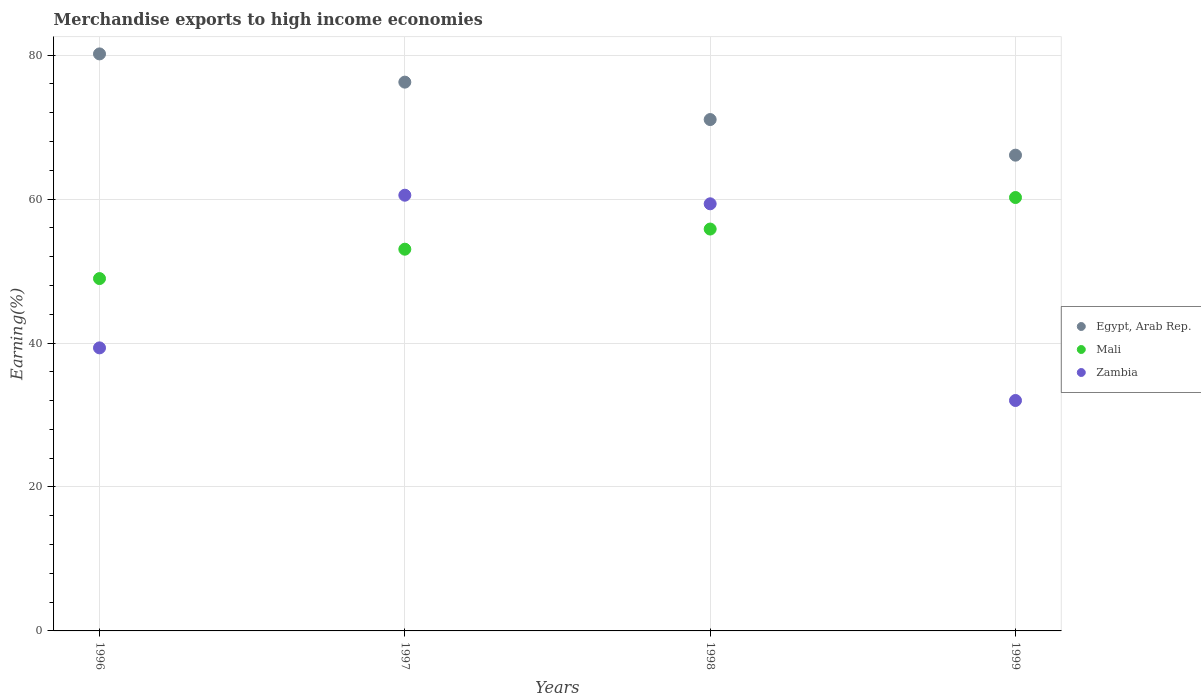Is the number of dotlines equal to the number of legend labels?
Provide a short and direct response. Yes. What is the percentage of amount earned from merchandise exports in Egypt, Arab Rep. in 1996?
Offer a terse response. 80.17. Across all years, what is the maximum percentage of amount earned from merchandise exports in Egypt, Arab Rep.?
Offer a terse response. 80.17. Across all years, what is the minimum percentage of amount earned from merchandise exports in Egypt, Arab Rep.?
Offer a terse response. 66.1. In which year was the percentage of amount earned from merchandise exports in Mali minimum?
Offer a terse response. 1996. What is the total percentage of amount earned from merchandise exports in Mali in the graph?
Ensure brevity in your answer.  218.04. What is the difference between the percentage of amount earned from merchandise exports in Zambia in 1996 and that in 1997?
Your answer should be very brief. -21.21. What is the difference between the percentage of amount earned from merchandise exports in Egypt, Arab Rep. in 1997 and the percentage of amount earned from merchandise exports in Mali in 1999?
Make the answer very short. 16.03. What is the average percentage of amount earned from merchandise exports in Mali per year?
Keep it short and to the point. 54.51. In the year 1998, what is the difference between the percentage of amount earned from merchandise exports in Mali and percentage of amount earned from merchandise exports in Egypt, Arab Rep.?
Ensure brevity in your answer.  -15.21. What is the ratio of the percentage of amount earned from merchandise exports in Zambia in 1996 to that in 1998?
Your answer should be very brief. 0.66. Is the percentage of amount earned from merchandise exports in Egypt, Arab Rep. in 1996 less than that in 1999?
Ensure brevity in your answer.  No. What is the difference between the highest and the second highest percentage of amount earned from merchandise exports in Zambia?
Your response must be concise. 1.19. What is the difference between the highest and the lowest percentage of amount earned from merchandise exports in Egypt, Arab Rep.?
Provide a short and direct response. 14.07. In how many years, is the percentage of amount earned from merchandise exports in Mali greater than the average percentage of amount earned from merchandise exports in Mali taken over all years?
Offer a very short reply. 2. Is the sum of the percentage of amount earned from merchandise exports in Egypt, Arab Rep. in 1997 and 1998 greater than the maximum percentage of amount earned from merchandise exports in Mali across all years?
Provide a succinct answer. Yes. Does the percentage of amount earned from merchandise exports in Egypt, Arab Rep. monotonically increase over the years?
Your response must be concise. No. Is the percentage of amount earned from merchandise exports in Zambia strictly greater than the percentage of amount earned from merchandise exports in Egypt, Arab Rep. over the years?
Offer a very short reply. No. How many years are there in the graph?
Provide a short and direct response. 4. Does the graph contain any zero values?
Provide a succinct answer. No. Where does the legend appear in the graph?
Provide a succinct answer. Center right. What is the title of the graph?
Your answer should be compact. Merchandise exports to high income economies. What is the label or title of the X-axis?
Give a very brief answer. Years. What is the label or title of the Y-axis?
Ensure brevity in your answer.  Earning(%). What is the Earning(%) in Egypt, Arab Rep. in 1996?
Your answer should be very brief. 80.17. What is the Earning(%) in Mali in 1996?
Offer a very short reply. 48.95. What is the Earning(%) in Zambia in 1996?
Give a very brief answer. 39.32. What is the Earning(%) of Egypt, Arab Rep. in 1997?
Offer a terse response. 76.25. What is the Earning(%) of Mali in 1997?
Ensure brevity in your answer.  53.03. What is the Earning(%) of Zambia in 1997?
Make the answer very short. 60.54. What is the Earning(%) in Egypt, Arab Rep. in 1998?
Provide a succinct answer. 71.05. What is the Earning(%) in Mali in 1998?
Make the answer very short. 55.83. What is the Earning(%) in Zambia in 1998?
Provide a succinct answer. 59.34. What is the Earning(%) of Egypt, Arab Rep. in 1999?
Provide a short and direct response. 66.1. What is the Earning(%) of Mali in 1999?
Ensure brevity in your answer.  60.21. What is the Earning(%) in Zambia in 1999?
Provide a succinct answer. 32.01. Across all years, what is the maximum Earning(%) in Egypt, Arab Rep.?
Ensure brevity in your answer.  80.17. Across all years, what is the maximum Earning(%) of Mali?
Your response must be concise. 60.21. Across all years, what is the maximum Earning(%) of Zambia?
Offer a terse response. 60.54. Across all years, what is the minimum Earning(%) of Egypt, Arab Rep.?
Provide a short and direct response. 66.1. Across all years, what is the minimum Earning(%) in Mali?
Your answer should be compact. 48.95. Across all years, what is the minimum Earning(%) in Zambia?
Ensure brevity in your answer.  32.01. What is the total Earning(%) of Egypt, Arab Rep. in the graph?
Your response must be concise. 293.56. What is the total Earning(%) in Mali in the graph?
Your answer should be very brief. 218.04. What is the total Earning(%) of Zambia in the graph?
Offer a very short reply. 191.22. What is the difference between the Earning(%) in Egypt, Arab Rep. in 1996 and that in 1997?
Ensure brevity in your answer.  3.92. What is the difference between the Earning(%) in Mali in 1996 and that in 1997?
Give a very brief answer. -4.08. What is the difference between the Earning(%) of Zambia in 1996 and that in 1997?
Your response must be concise. -21.21. What is the difference between the Earning(%) of Egypt, Arab Rep. in 1996 and that in 1998?
Make the answer very short. 9.12. What is the difference between the Earning(%) in Mali in 1996 and that in 1998?
Your response must be concise. -6.88. What is the difference between the Earning(%) in Zambia in 1996 and that in 1998?
Provide a succinct answer. -20.02. What is the difference between the Earning(%) of Egypt, Arab Rep. in 1996 and that in 1999?
Keep it short and to the point. 14.07. What is the difference between the Earning(%) in Mali in 1996 and that in 1999?
Make the answer very short. -11.26. What is the difference between the Earning(%) in Zambia in 1996 and that in 1999?
Your response must be concise. 7.31. What is the difference between the Earning(%) in Egypt, Arab Rep. in 1997 and that in 1998?
Provide a short and direct response. 5.2. What is the difference between the Earning(%) in Mali in 1997 and that in 1998?
Give a very brief answer. -2.8. What is the difference between the Earning(%) of Zambia in 1997 and that in 1998?
Give a very brief answer. 1.19. What is the difference between the Earning(%) in Egypt, Arab Rep. in 1997 and that in 1999?
Give a very brief answer. 10.15. What is the difference between the Earning(%) of Mali in 1997 and that in 1999?
Your answer should be very brief. -7.18. What is the difference between the Earning(%) of Zambia in 1997 and that in 1999?
Offer a terse response. 28.52. What is the difference between the Earning(%) of Egypt, Arab Rep. in 1998 and that in 1999?
Provide a succinct answer. 4.95. What is the difference between the Earning(%) of Mali in 1998 and that in 1999?
Ensure brevity in your answer.  -4.38. What is the difference between the Earning(%) in Zambia in 1998 and that in 1999?
Your answer should be very brief. 27.33. What is the difference between the Earning(%) of Egypt, Arab Rep. in 1996 and the Earning(%) of Mali in 1997?
Your answer should be very brief. 27.13. What is the difference between the Earning(%) of Egypt, Arab Rep. in 1996 and the Earning(%) of Zambia in 1997?
Provide a short and direct response. 19.63. What is the difference between the Earning(%) in Mali in 1996 and the Earning(%) in Zambia in 1997?
Offer a very short reply. -11.58. What is the difference between the Earning(%) of Egypt, Arab Rep. in 1996 and the Earning(%) of Mali in 1998?
Ensure brevity in your answer.  24.33. What is the difference between the Earning(%) of Egypt, Arab Rep. in 1996 and the Earning(%) of Zambia in 1998?
Make the answer very short. 20.83. What is the difference between the Earning(%) in Mali in 1996 and the Earning(%) in Zambia in 1998?
Offer a very short reply. -10.39. What is the difference between the Earning(%) in Egypt, Arab Rep. in 1996 and the Earning(%) in Mali in 1999?
Your response must be concise. 19.95. What is the difference between the Earning(%) of Egypt, Arab Rep. in 1996 and the Earning(%) of Zambia in 1999?
Your answer should be compact. 48.15. What is the difference between the Earning(%) in Mali in 1996 and the Earning(%) in Zambia in 1999?
Keep it short and to the point. 16.94. What is the difference between the Earning(%) in Egypt, Arab Rep. in 1997 and the Earning(%) in Mali in 1998?
Provide a short and direct response. 20.41. What is the difference between the Earning(%) in Egypt, Arab Rep. in 1997 and the Earning(%) in Zambia in 1998?
Your response must be concise. 16.9. What is the difference between the Earning(%) of Mali in 1997 and the Earning(%) of Zambia in 1998?
Offer a terse response. -6.31. What is the difference between the Earning(%) in Egypt, Arab Rep. in 1997 and the Earning(%) in Mali in 1999?
Offer a terse response. 16.03. What is the difference between the Earning(%) of Egypt, Arab Rep. in 1997 and the Earning(%) of Zambia in 1999?
Your answer should be very brief. 44.23. What is the difference between the Earning(%) of Mali in 1997 and the Earning(%) of Zambia in 1999?
Keep it short and to the point. 21.02. What is the difference between the Earning(%) of Egypt, Arab Rep. in 1998 and the Earning(%) of Mali in 1999?
Your response must be concise. 10.83. What is the difference between the Earning(%) of Egypt, Arab Rep. in 1998 and the Earning(%) of Zambia in 1999?
Your answer should be compact. 39.03. What is the difference between the Earning(%) in Mali in 1998 and the Earning(%) in Zambia in 1999?
Offer a terse response. 23.82. What is the average Earning(%) of Egypt, Arab Rep. per year?
Give a very brief answer. 73.39. What is the average Earning(%) of Mali per year?
Provide a short and direct response. 54.51. What is the average Earning(%) in Zambia per year?
Your answer should be very brief. 47.8. In the year 1996, what is the difference between the Earning(%) of Egypt, Arab Rep. and Earning(%) of Mali?
Provide a succinct answer. 31.21. In the year 1996, what is the difference between the Earning(%) in Egypt, Arab Rep. and Earning(%) in Zambia?
Provide a succinct answer. 40.84. In the year 1996, what is the difference between the Earning(%) of Mali and Earning(%) of Zambia?
Keep it short and to the point. 9.63. In the year 1997, what is the difference between the Earning(%) in Egypt, Arab Rep. and Earning(%) in Mali?
Your answer should be very brief. 23.21. In the year 1997, what is the difference between the Earning(%) in Egypt, Arab Rep. and Earning(%) in Zambia?
Your response must be concise. 15.71. In the year 1997, what is the difference between the Earning(%) in Mali and Earning(%) in Zambia?
Offer a terse response. -7.5. In the year 1998, what is the difference between the Earning(%) of Egypt, Arab Rep. and Earning(%) of Mali?
Provide a succinct answer. 15.21. In the year 1998, what is the difference between the Earning(%) of Egypt, Arab Rep. and Earning(%) of Zambia?
Your response must be concise. 11.71. In the year 1998, what is the difference between the Earning(%) of Mali and Earning(%) of Zambia?
Ensure brevity in your answer.  -3.51. In the year 1999, what is the difference between the Earning(%) of Egypt, Arab Rep. and Earning(%) of Mali?
Keep it short and to the point. 5.89. In the year 1999, what is the difference between the Earning(%) of Egypt, Arab Rep. and Earning(%) of Zambia?
Keep it short and to the point. 34.09. In the year 1999, what is the difference between the Earning(%) of Mali and Earning(%) of Zambia?
Make the answer very short. 28.2. What is the ratio of the Earning(%) in Egypt, Arab Rep. in 1996 to that in 1997?
Your answer should be very brief. 1.05. What is the ratio of the Earning(%) in Mali in 1996 to that in 1997?
Provide a short and direct response. 0.92. What is the ratio of the Earning(%) in Zambia in 1996 to that in 1997?
Offer a terse response. 0.65. What is the ratio of the Earning(%) of Egypt, Arab Rep. in 1996 to that in 1998?
Your answer should be compact. 1.13. What is the ratio of the Earning(%) in Mali in 1996 to that in 1998?
Your answer should be very brief. 0.88. What is the ratio of the Earning(%) in Zambia in 1996 to that in 1998?
Give a very brief answer. 0.66. What is the ratio of the Earning(%) in Egypt, Arab Rep. in 1996 to that in 1999?
Provide a succinct answer. 1.21. What is the ratio of the Earning(%) of Mali in 1996 to that in 1999?
Offer a very short reply. 0.81. What is the ratio of the Earning(%) of Zambia in 1996 to that in 1999?
Offer a terse response. 1.23. What is the ratio of the Earning(%) of Egypt, Arab Rep. in 1997 to that in 1998?
Provide a succinct answer. 1.07. What is the ratio of the Earning(%) of Mali in 1997 to that in 1998?
Provide a short and direct response. 0.95. What is the ratio of the Earning(%) of Zambia in 1997 to that in 1998?
Your response must be concise. 1.02. What is the ratio of the Earning(%) in Egypt, Arab Rep. in 1997 to that in 1999?
Your response must be concise. 1.15. What is the ratio of the Earning(%) in Mali in 1997 to that in 1999?
Make the answer very short. 0.88. What is the ratio of the Earning(%) in Zambia in 1997 to that in 1999?
Ensure brevity in your answer.  1.89. What is the ratio of the Earning(%) in Egypt, Arab Rep. in 1998 to that in 1999?
Ensure brevity in your answer.  1.07. What is the ratio of the Earning(%) of Mali in 1998 to that in 1999?
Your answer should be very brief. 0.93. What is the ratio of the Earning(%) in Zambia in 1998 to that in 1999?
Your answer should be very brief. 1.85. What is the difference between the highest and the second highest Earning(%) in Egypt, Arab Rep.?
Your answer should be compact. 3.92. What is the difference between the highest and the second highest Earning(%) of Mali?
Your response must be concise. 4.38. What is the difference between the highest and the second highest Earning(%) in Zambia?
Offer a terse response. 1.19. What is the difference between the highest and the lowest Earning(%) of Egypt, Arab Rep.?
Offer a terse response. 14.07. What is the difference between the highest and the lowest Earning(%) of Mali?
Provide a short and direct response. 11.26. What is the difference between the highest and the lowest Earning(%) of Zambia?
Keep it short and to the point. 28.52. 